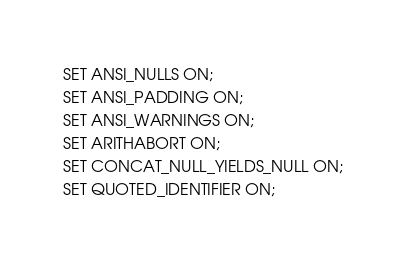<code> <loc_0><loc_0><loc_500><loc_500><_SQL_>SET ANSI_NULLS ON;
SET ANSI_PADDING ON;
SET ANSI_WARNINGS ON;
SET ARITHABORT ON;
SET CONCAT_NULL_YIELDS_NULL ON;
SET QUOTED_IDENTIFIER ON;</code> 